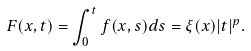<formula> <loc_0><loc_0><loc_500><loc_500>F ( x , t ) = \int _ { 0 } ^ { t } f ( x , s ) d s = \xi ( x ) | t | ^ { p } .</formula> 